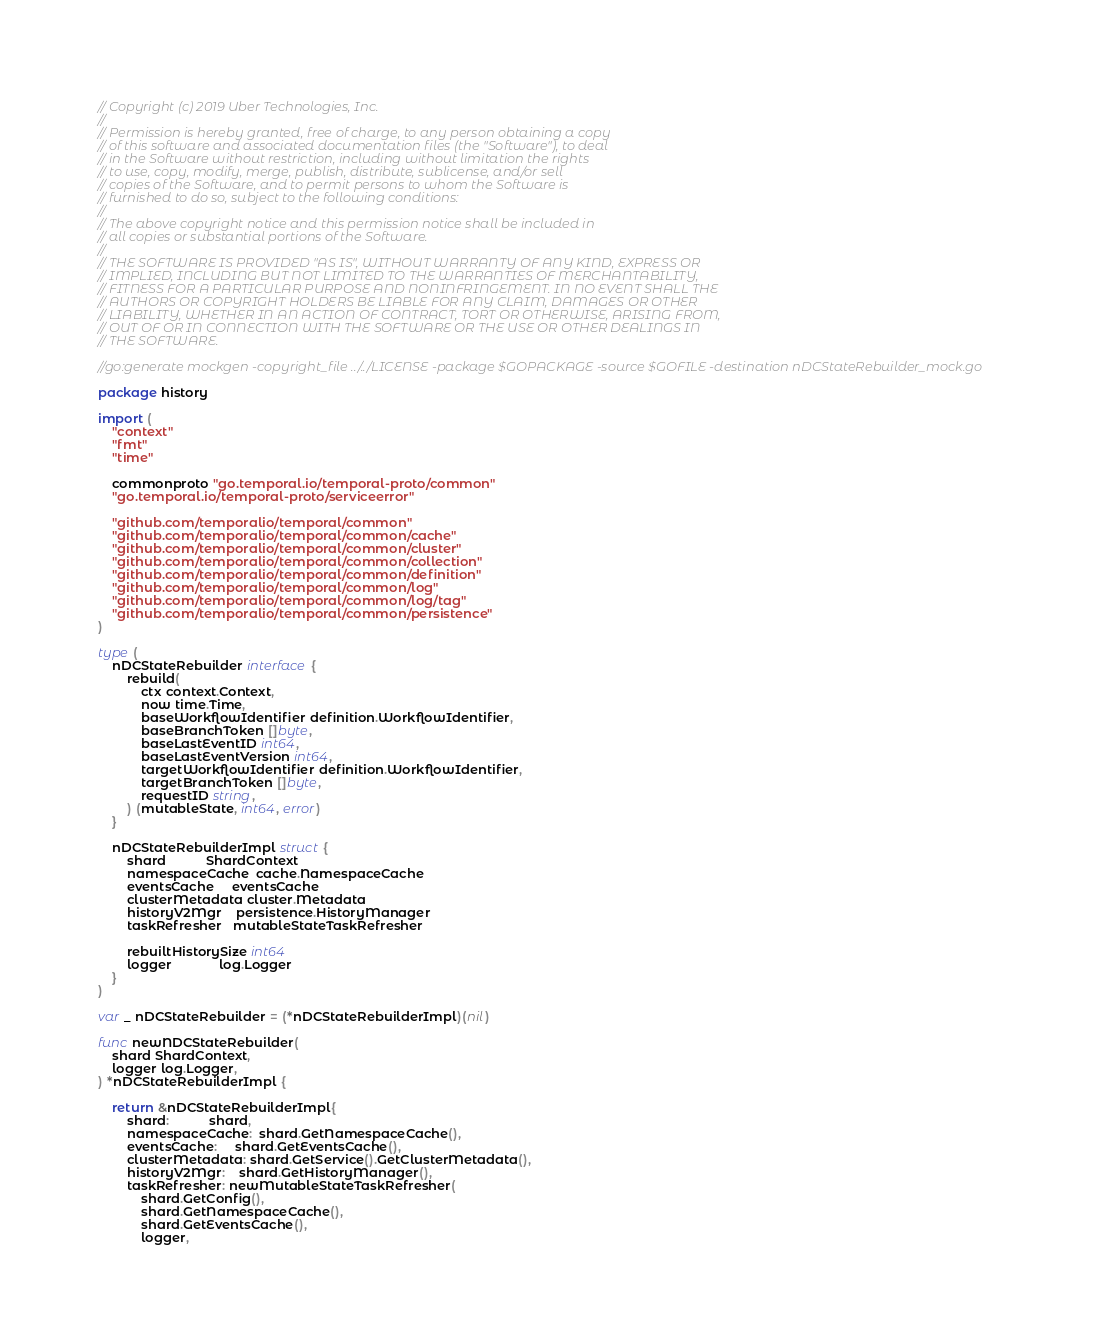Convert code to text. <code><loc_0><loc_0><loc_500><loc_500><_Go_>// Copyright (c) 2019 Uber Technologies, Inc.
//
// Permission is hereby granted, free of charge, to any person obtaining a copy
// of this software and associated documentation files (the "Software"), to deal
// in the Software without restriction, including without limitation the rights
// to use, copy, modify, merge, publish, distribute, sublicense, and/or sell
// copies of the Software, and to permit persons to whom the Software is
// furnished to do so, subject to the following conditions:
//
// The above copyright notice and this permission notice shall be included in
// all copies or substantial portions of the Software.
//
// THE SOFTWARE IS PROVIDED "AS IS", WITHOUT WARRANTY OF ANY KIND, EXPRESS OR
// IMPLIED, INCLUDING BUT NOT LIMITED TO THE WARRANTIES OF MERCHANTABILITY,
// FITNESS FOR A PARTICULAR PURPOSE AND NONINFRINGEMENT. IN NO EVENT SHALL THE
// AUTHORS OR COPYRIGHT HOLDERS BE LIABLE FOR ANY CLAIM, DAMAGES OR OTHER
// LIABILITY, WHETHER IN AN ACTION OF CONTRACT, TORT OR OTHERWISE, ARISING FROM,
// OUT OF OR IN CONNECTION WITH THE SOFTWARE OR THE USE OR OTHER DEALINGS IN
// THE SOFTWARE.

//go:generate mockgen -copyright_file ../../LICENSE -package $GOPACKAGE -source $GOFILE -destination nDCStateRebuilder_mock.go

package history

import (
	"context"
	"fmt"
	"time"

	commonproto "go.temporal.io/temporal-proto/common"
	"go.temporal.io/temporal-proto/serviceerror"

	"github.com/temporalio/temporal/common"
	"github.com/temporalio/temporal/common/cache"
	"github.com/temporalio/temporal/common/cluster"
	"github.com/temporalio/temporal/common/collection"
	"github.com/temporalio/temporal/common/definition"
	"github.com/temporalio/temporal/common/log"
	"github.com/temporalio/temporal/common/log/tag"
	"github.com/temporalio/temporal/common/persistence"
)

type (
	nDCStateRebuilder interface {
		rebuild(
			ctx context.Context,
			now time.Time,
			baseWorkflowIdentifier definition.WorkflowIdentifier,
			baseBranchToken []byte,
			baseLastEventID int64,
			baseLastEventVersion int64,
			targetWorkflowIdentifier definition.WorkflowIdentifier,
			targetBranchToken []byte,
			requestID string,
		) (mutableState, int64, error)
	}

	nDCStateRebuilderImpl struct {
		shard           ShardContext
		namespaceCache  cache.NamespaceCache
		eventsCache     eventsCache
		clusterMetadata cluster.Metadata
		historyV2Mgr    persistence.HistoryManager
		taskRefresher   mutableStateTaskRefresher

		rebuiltHistorySize int64
		logger             log.Logger
	}
)

var _ nDCStateRebuilder = (*nDCStateRebuilderImpl)(nil)

func newNDCStateRebuilder(
	shard ShardContext,
	logger log.Logger,
) *nDCStateRebuilderImpl {

	return &nDCStateRebuilderImpl{
		shard:           shard,
		namespaceCache:  shard.GetNamespaceCache(),
		eventsCache:     shard.GetEventsCache(),
		clusterMetadata: shard.GetService().GetClusterMetadata(),
		historyV2Mgr:    shard.GetHistoryManager(),
		taskRefresher: newMutableStateTaskRefresher(
			shard.GetConfig(),
			shard.GetNamespaceCache(),
			shard.GetEventsCache(),
			logger,</code> 